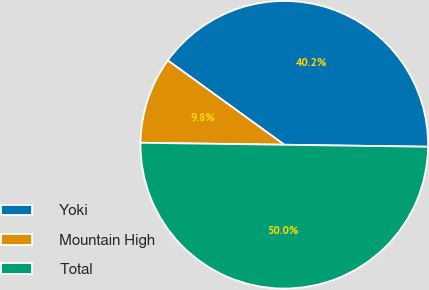<chart> <loc_0><loc_0><loc_500><loc_500><pie_chart><fcel>Yoki<fcel>Mountain High<fcel>Total<nl><fcel>40.25%<fcel>9.75%<fcel>50.0%<nl></chart> 